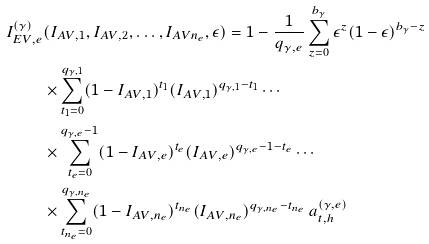Convert formula to latex. <formula><loc_0><loc_0><loc_500><loc_500>I _ { E V , e } ^ { ( \gamma ) } & ( I _ { A V , 1 } , I _ { A V , 2 } , \dots , I _ { A V n _ { e } } , \epsilon ) = 1 - \frac { 1 } { q _ { \gamma , e } } \sum _ { z = 0 } ^ { b _ { \gamma } } \epsilon ^ { z } ( 1 - \epsilon ) ^ { b _ { \gamma } - z } \\ \, & \times \sum _ { t _ { 1 } = 0 } ^ { q _ { \gamma , 1 } } ( 1 - I _ { A V , 1 } ) ^ { t _ { 1 } } ( I _ { A V , 1 } ) ^ { q _ { \gamma , 1 } - t _ { 1 } } \cdots \\ \, & \times \sum _ { t _ { e } = 0 } ^ { q _ { \gamma , e } - 1 } ( 1 - I _ { A V , e } ) ^ { t _ { e } } ( I _ { A V , e } ) ^ { q _ { \gamma , e } - 1 - t _ { e } } \cdots \\ \, & \times \sum _ { t _ { n _ { e } } = 0 } ^ { q _ { \gamma , n _ { e } } } ( 1 - I _ { A V , n _ { e } } ) ^ { t _ { n _ { e } } } ( I _ { A V , n _ { e } } ) ^ { q _ { \gamma , n _ { e } } - t _ { n _ { e } } } \, a _ { t , h } ^ { ( \gamma , e ) }</formula> 